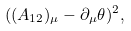<formula> <loc_0><loc_0><loc_500><loc_500>( ( A _ { 1 2 } ) _ { \mu } - \partial _ { \mu } \theta ) ^ { 2 } ,</formula> 